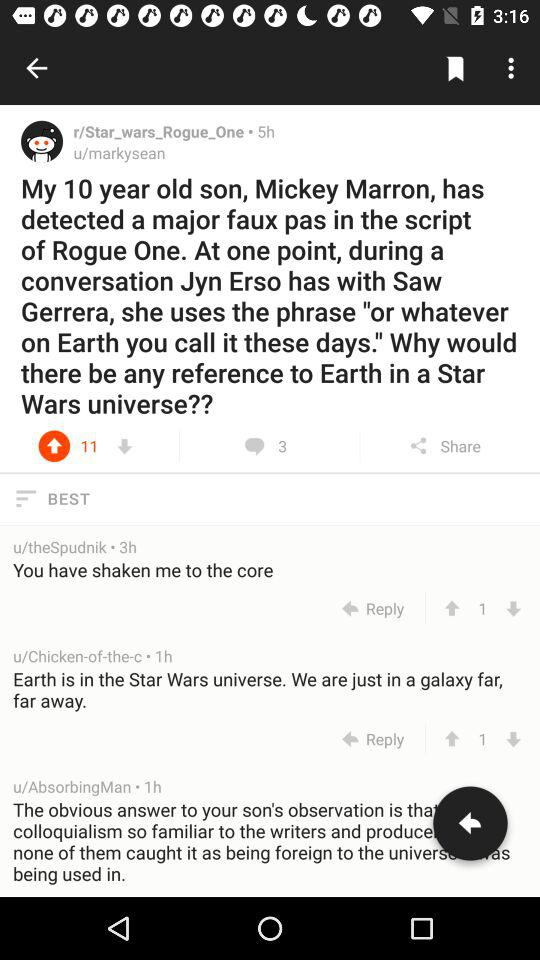How many comments in total are there? There are 3 comments in total. 